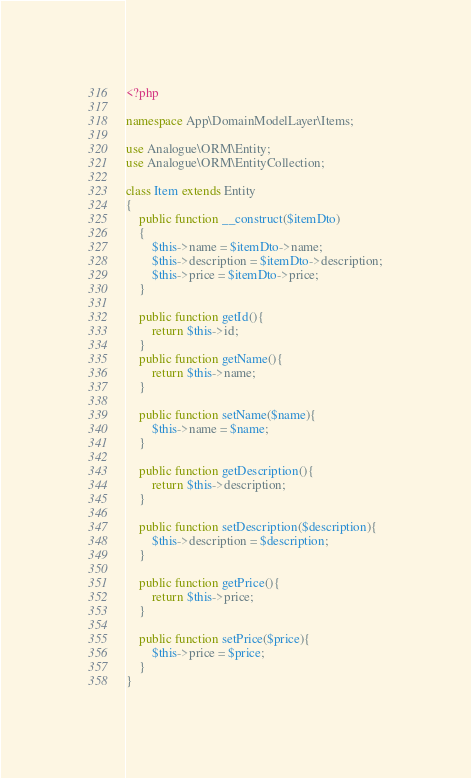<code> <loc_0><loc_0><loc_500><loc_500><_PHP_><?php

namespace App\DomainModelLayer\Items;

use Analogue\ORM\Entity;
use Analogue\ORM\EntityCollection;

class Item extends Entity
{
	public function __construct($itemDto)
    {
    	$this->name = $itemDto->name;
        $this->description = $itemDto->description;
        $this->price = $itemDto->price;
    }

    public function getId(){
        return $this->id;
    }
    public function getName(){
    	return $this->name;
    }

    public function setName($name){
    	$this->name = $name;
    }

    public function getDescription(){
        return $this->description;
    }

    public function setDescription($description){
        $this->description = $description;
    }

    public function getPrice(){
        return $this->price;
    }

    public function setPrice($price){
        $this->price = $price;
    }
}</code> 